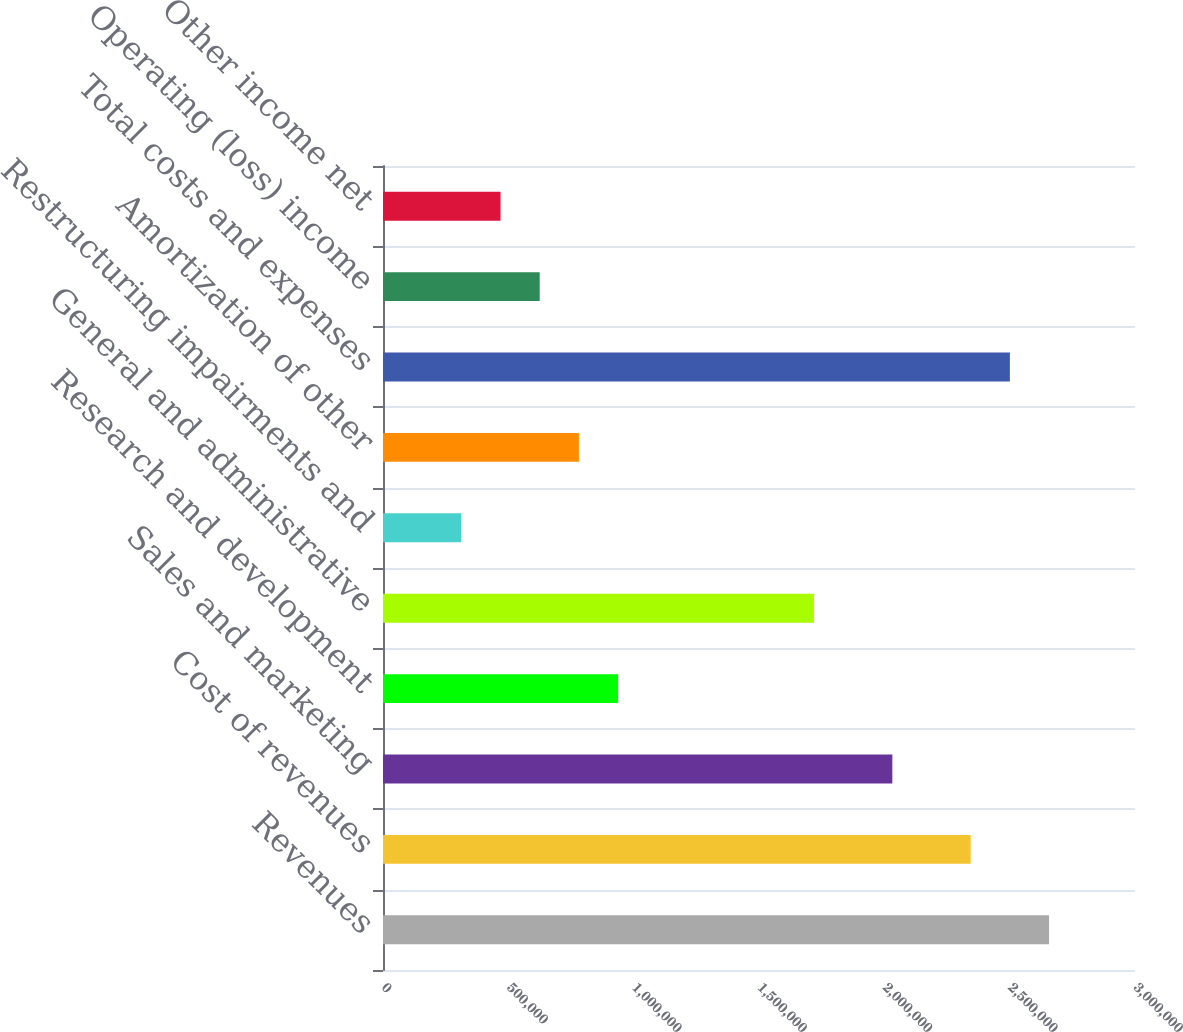Convert chart to OTSL. <chart><loc_0><loc_0><loc_500><loc_500><bar_chart><fcel>Revenues<fcel>Cost of revenues<fcel>Sales and marketing<fcel>Research and development<fcel>General and administrative<fcel>Restructuring impairments and<fcel>Amortization of other<fcel>Total costs and expenses<fcel>Operating (loss) income<fcel>Other income net<nl><fcel>2.6571e+06<fcel>2.3445e+06<fcel>2.0319e+06<fcel>937799<fcel>1.7193e+06<fcel>312600<fcel>781499<fcel>2.5008e+06<fcel>625199<fcel>468899<nl></chart> 